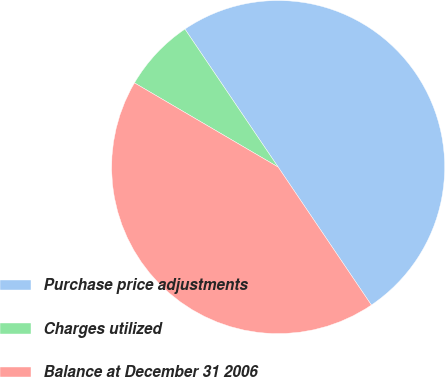<chart> <loc_0><loc_0><loc_500><loc_500><pie_chart><fcel>Purchase price adjustments<fcel>Charges utilized<fcel>Balance at December 31 2006<nl><fcel>50.0%<fcel>7.11%<fcel>42.89%<nl></chart> 